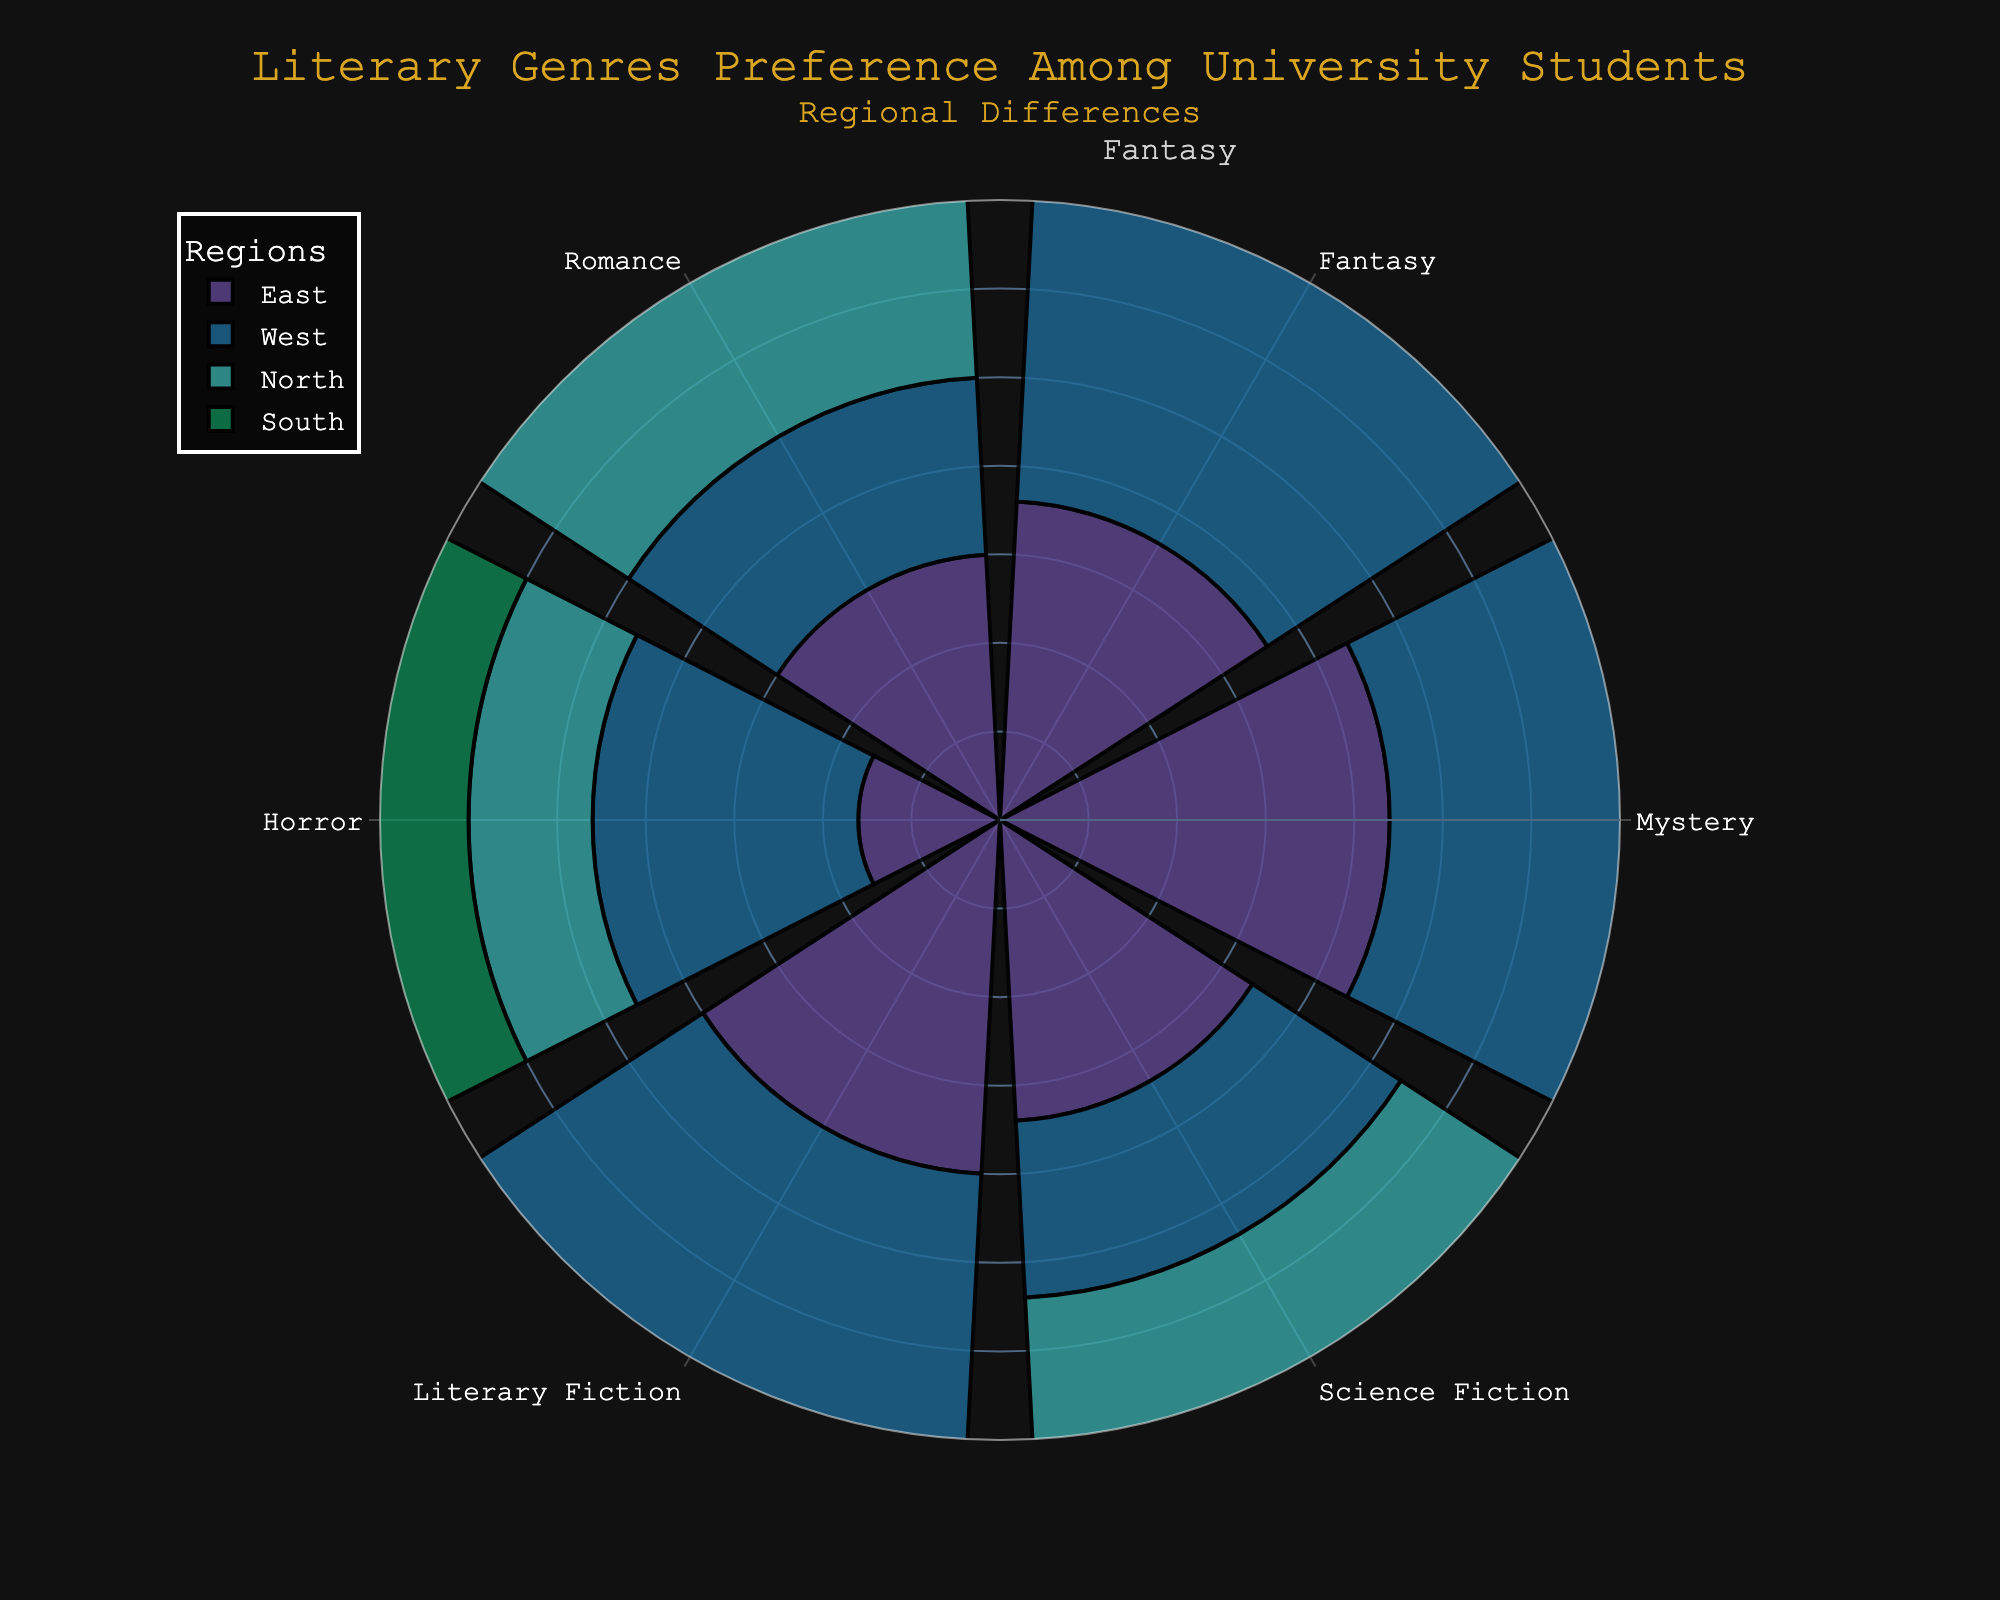What's the most preferred literary genre among students in the North? The most preferred genre will have the longest bar segment in the North region. Looking at the chart segment for the North region, the Romance genre has the largest radial bar.
Answer: Romance Which region shows the highest preference for Fantasy? Compare the bar lengths of the Fantasy genre across all regions. The West region has the highest preference as it has the longest bar for Fantasy.
Answer: West What is the combined preference percentage for Mystery and Science Fiction genres in the East region? Sum the preference percentages for Mystery and Science Fiction in the East region: 22 (Mystery) + 17 (Science Fiction).
Answer: 39 Is the preference for Horror in the West greater than in the East? Compare the bar lengths for the Horror genre in both the West and East regions. The West region has a longer bar for Horror (15) compared to the East (8).
Answer: Yes Which literary genre has the smallest preference in the South region? Identify the shortest bar segment within the South region. The smallest bar corresponds to Horror.
Answer: Horror What is the average preference percentage for Literary Fiction across all regions? Add up the preference percentages of Literary Fiction for all regions (20 + 20 + 18 + 15) and divide by the number of regions (4). (20 + 20 + 18 + 15) / 4 = 73 / 4.
Answer: 18.25 Does the East or the South region have a higher overall preference for Romance? Compare the bar lengths for Romance in the East (15) versus the South (20). The South region has a longer bar for Romance.
Answer: South What is the difference in preference percentage for Mystery between the North and West regions? Subtract the preference percentage for Mystery in the North (15) from that in the West (20). 20 - 15.
Answer: 5 Which two genres have equal preference percentages in any region? Look for bars of the same length within any region. In the West region, Mystery and Literary Fiction both have a preference percentage of 20.
Answer: Mystery and Literary Fiction What region has the most balanced preference percentages among the listed genres? Observe the uniformity of bar lengths in each region. The South region presents the most balanced preference percentages across all genres.
Answer: South 